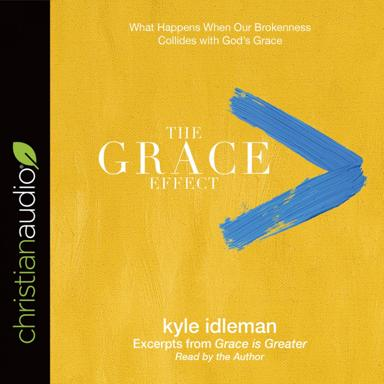What is the name of the work mentioned in the image? The work prominently featured in the image is titled "The Grace Effect," and it is directly related to Kyle Idleman's previous inspirational work, "Grace is Greater," highlighting key excerpts for listeners to reflect upon. 